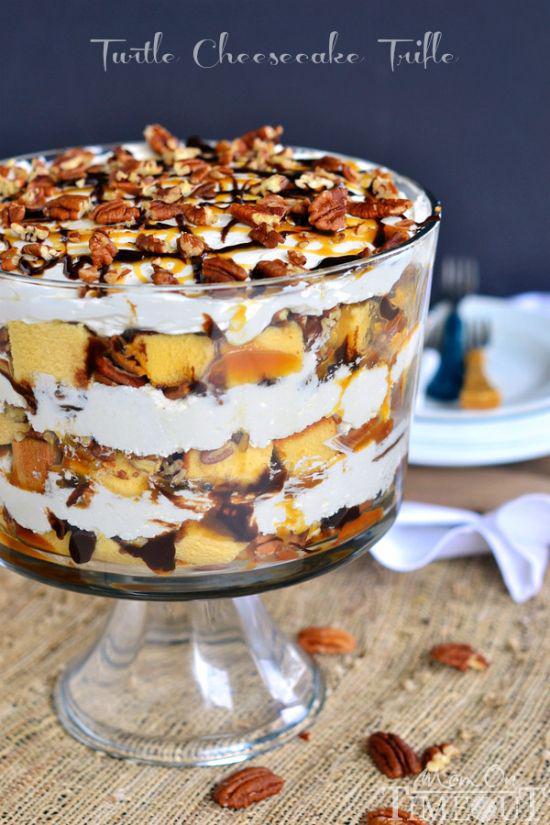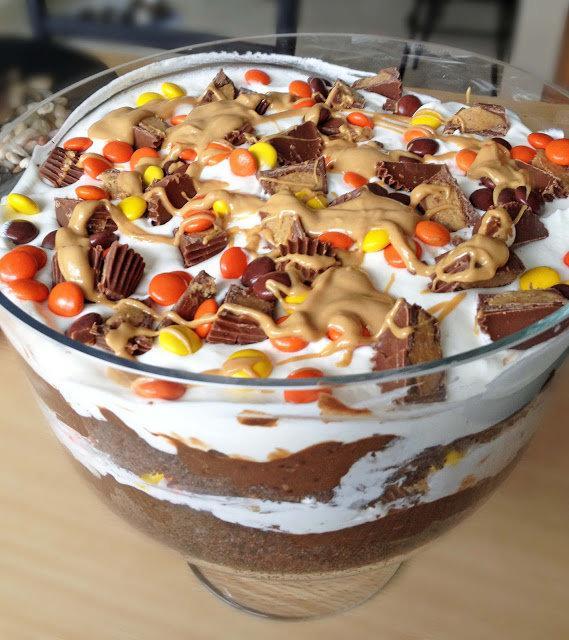The first image is the image on the left, the second image is the image on the right. For the images shown, is this caption "Some of the desserts are dished out in individual servings." true? Answer yes or no. No. The first image is the image on the left, the second image is the image on the right. For the images displayed, is the sentence "No more than one dessert is shown on each picture." factually correct? Answer yes or no. Yes. 